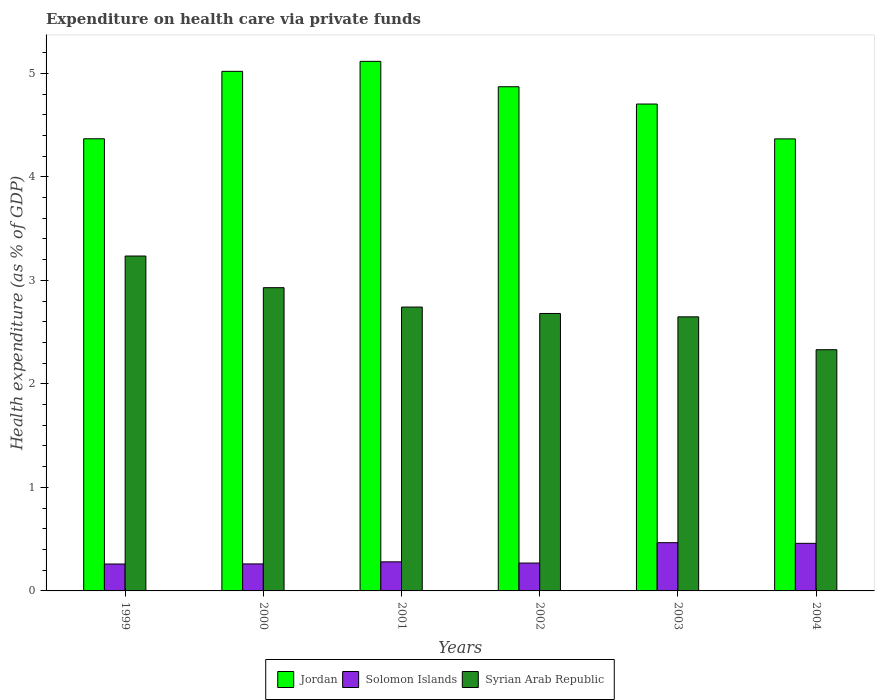How many groups of bars are there?
Offer a very short reply. 6. Are the number of bars per tick equal to the number of legend labels?
Offer a terse response. Yes. How many bars are there on the 2nd tick from the right?
Your answer should be compact. 3. What is the expenditure made on health care in Syrian Arab Republic in 2002?
Provide a short and direct response. 2.68. Across all years, what is the maximum expenditure made on health care in Syrian Arab Republic?
Give a very brief answer. 3.24. Across all years, what is the minimum expenditure made on health care in Syrian Arab Republic?
Your answer should be very brief. 2.33. In which year was the expenditure made on health care in Syrian Arab Republic maximum?
Your answer should be compact. 1999. What is the total expenditure made on health care in Solomon Islands in the graph?
Provide a succinct answer. 2. What is the difference between the expenditure made on health care in Jordan in 2000 and that in 2004?
Give a very brief answer. 0.65. What is the difference between the expenditure made on health care in Jordan in 2002 and the expenditure made on health care in Syrian Arab Republic in 1999?
Offer a terse response. 1.64. What is the average expenditure made on health care in Jordan per year?
Offer a terse response. 4.74. In the year 2003, what is the difference between the expenditure made on health care in Solomon Islands and expenditure made on health care in Syrian Arab Republic?
Keep it short and to the point. -2.18. In how many years, is the expenditure made on health care in Jordan greater than 1.2 %?
Offer a very short reply. 6. What is the ratio of the expenditure made on health care in Jordan in 2000 to that in 2001?
Your answer should be very brief. 0.98. Is the expenditure made on health care in Syrian Arab Republic in 2000 less than that in 2003?
Provide a succinct answer. No. Is the difference between the expenditure made on health care in Solomon Islands in 2001 and 2004 greater than the difference between the expenditure made on health care in Syrian Arab Republic in 2001 and 2004?
Ensure brevity in your answer.  No. What is the difference between the highest and the second highest expenditure made on health care in Solomon Islands?
Keep it short and to the point. 0.01. What is the difference between the highest and the lowest expenditure made on health care in Syrian Arab Republic?
Your response must be concise. 0.91. Is the sum of the expenditure made on health care in Solomon Islands in 2002 and 2004 greater than the maximum expenditure made on health care in Syrian Arab Republic across all years?
Ensure brevity in your answer.  No. What does the 1st bar from the left in 2000 represents?
Your answer should be very brief. Jordan. What does the 2nd bar from the right in 2004 represents?
Offer a terse response. Solomon Islands. How many bars are there?
Your response must be concise. 18. What is the difference between two consecutive major ticks on the Y-axis?
Your response must be concise. 1. Are the values on the major ticks of Y-axis written in scientific E-notation?
Give a very brief answer. No. Does the graph contain grids?
Provide a short and direct response. No. Where does the legend appear in the graph?
Make the answer very short. Bottom center. How many legend labels are there?
Provide a succinct answer. 3. What is the title of the graph?
Offer a terse response. Expenditure on health care via private funds. What is the label or title of the X-axis?
Provide a short and direct response. Years. What is the label or title of the Y-axis?
Your answer should be very brief. Health expenditure (as % of GDP). What is the Health expenditure (as % of GDP) in Jordan in 1999?
Provide a succinct answer. 4.37. What is the Health expenditure (as % of GDP) of Solomon Islands in 1999?
Keep it short and to the point. 0.26. What is the Health expenditure (as % of GDP) of Syrian Arab Republic in 1999?
Your answer should be very brief. 3.24. What is the Health expenditure (as % of GDP) in Jordan in 2000?
Give a very brief answer. 5.02. What is the Health expenditure (as % of GDP) of Solomon Islands in 2000?
Keep it short and to the point. 0.26. What is the Health expenditure (as % of GDP) in Syrian Arab Republic in 2000?
Give a very brief answer. 2.93. What is the Health expenditure (as % of GDP) in Jordan in 2001?
Keep it short and to the point. 5.12. What is the Health expenditure (as % of GDP) of Solomon Islands in 2001?
Provide a short and direct response. 0.28. What is the Health expenditure (as % of GDP) in Syrian Arab Republic in 2001?
Give a very brief answer. 2.74. What is the Health expenditure (as % of GDP) of Jordan in 2002?
Provide a succinct answer. 4.87. What is the Health expenditure (as % of GDP) of Solomon Islands in 2002?
Your answer should be very brief. 0.27. What is the Health expenditure (as % of GDP) in Syrian Arab Republic in 2002?
Provide a succinct answer. 2.68. What is the Health expenditure (as % of GDP) of Jordan in 2003?
Give a very brief answer. 4.7. What is the Health expenditure (as % of GDP) in Solomon Islands in 2003?
Offer a very short reply. 0.47. What is the Health expenditure (as % of GDP) in Syrian Arab Republic in 2003?
Provide a short and direct response. 2.65. What is the Health expenditure (as % of GDP) in Jordan in 2004?
Make the answer very short. 4.37. What is the Health expenditure (as % of GDP) of Solomon Islands in 2004?
Your answer should be compact. 0.46. What is the Health expenditure (as % of GDP) of Syrian Arab Republic in 2004?
Your answer should be compact. 2.33. Across all years, what is the maximum Health expenditure (as % of GDP) of Jordan?
Provide a succinct answer. 5.12. Across all years, what is the maximum Health expenditure (as % of GDP) in Solomon Islands?
Make the answer very short. 0.47. Across all years, what is the maximum Health expenditure (as % of GDP) in Syrian Arab Republic?
Provide a short and direct response. 3.24. Across all years, what is the minimum Health expenditure (as % of GDP) of Jordan?
Ensure brevity in your answer.  4.37. Across all years, what is the minimum Health expenditure (as % of GDP) in Solomon Islands?
Your response must be concise. 0.26. Across all years, what is the minimum Health expenditure (as % of GDP) in Syrian Arab Republic?
Keep it short and to the point. 2.33. What is the total Health expenditure (as % of GDP) of Jordan in the graph?
Your answer should be very brief. 28.44. What is the total Health expenditure (as % of GDP) in Solomon Islands in the graph?
Your response must be concise. 2. What is the total Health expenditure (as % of GDP) in Syrian Arab Republic in the graph?
Keep it short and to the point. 16.57. What is the difference between the Health expenditure (as % of GDP) of Jordan in 1999 and that in 2000?
Offer a very short reply. -0.65. What is the difference between the Health expenditure (as % of GDP) of Solomon Islands in 1999 and that in 2000?
Ensure brevity in your answer.  -0. What is the difference between the Health expenditure (as % of GDP) in Syrian Arab Republic in 1999 and that in 2000?
Offer a terse response. 0.31. What is the difference between the Health expenditure (as % of GDP) of Jordan in 1999 and that in 2001?
Offer a very short reply. -0.75. What is the difference between the Health expenditure (as % of GDP) of Solomon Islands in 1999 and that in 2001?
Keep it short and to the point. -0.02. What is the difference between the Health expenditure (as % of GDP) in Syrian Arab Republic in 1999 and that in 2001?
Keep it short and to the point. 0.49. What is the difference between the Health expenditure (as % of GDP) of Jordan in 1999 and that in 2002?
Your answer should be very brief. -0.5. What is the difference between the Health expenditure (as % of GDP) of Solomon Islands in 1999 and that in 2002?
Keep it short and to the point. -0.01. What is the difference between the Health expenditure (as % of GDP) of Syrian Arab Republic in 1999 and that in 2002?
Provide a succinct answer. 0.56. What is the difference between the Health expenditure (as % of GDP) of Jordan in 1999 and that in 2003?
Your answer should be compact. -0.34. What is the difference between the Health expenditure (as % of GDP) of Solomon Islands in 1999 and that in 2003?
Your answer should be compact. -0.21. What is the difference between the Health expenditure (as % of GDP) in Syrian Arab Republic in 1999 and that in 2003?
Provide a succinct answer. 0.59. What is the difference between the Health expenditure (as % of GDP) in Jordan in 1999 and that in 2004?
Keep it short and to the point. 0. What is the difference between the Health expenditure (as % of GDP) of Solomon Islands in 1999 and that in 2004?
Make the answer very short. -0.2. What is the difference between the Health expenditure (as % of GDP) of Syrian Arab Republic in 1999 and that in 2004?
Keep it short and to the point. 0.91. What is the difference between the Health expenditure (as % of GDP) of Jordan in 2000 and that in 2001?
Provide a short and direct response. -0.1. What is the difference between the Health expenditure (as % of GDP) in Solomon Islands in 2000 and that in 2001?
Give a very brief answer. -0.02. What is the difference between the Health expenditure (as % of GDP) in Syrian Arab Republic in 2000 and that in 2001?
Provide a short and direct response. 0.19. What is the difference between the Health expenditure (as % of GDP) of Jordan in 2000 and that in 2002?
Make the answer very short. 0.15. What is the difference between the Health expenditure (as % of GDP) in Solomon Islands in 2000 and that in 2002?
Keep it short and to the point. -0.01. What is the difference between the Health expenditure (as % of GDP) of Syrian Arab Republic in 2000 and that in 2002?
Ensure brevity in your answer.  0.25. What is the difference between the Health expenditure (as % of GDP) in Jordan in 2000 and that in 2003?
Your answer should be very brief. 0.32. What is the difference between the Health expenditure (as % of GDP) in Solomon Islands in 2000 and that in 2003?
Ensure brevity in your answer.  -0.21. What is the difference between the Health expenditure (as % of GDP) of Syrian Arab Republic in 2000 and that in 2003?
Your response must be concise. 0.28. What is the difference between the Health expenditure (as % of GDP) of Jordan in 2000 and that in 2004?
Ensure brevity in your answer.  0.65. What is the difference between the Health expenditure (as % of GDP) in Solomon Islands in 2000 and that in 2004?
Your answer should be compact. -0.2. What is the difference between the Health expenditure (as % of GDP) of Syrian Arab Republic in 2000 and that in 2004?
Ensure brevity in your answer.  0.6. What is the difference between the Health expenditure (as % of GDP) in Jordan in 2001 and that in 2002?
Your answer should be compact. 0.25. What is the difference between the Health expenditure (as % of GDP) of Solomon Islands in 2001 and that in 2002?
Ensure brevity in your answer.  0.01. What is the difference between the Health expenditure (as % of GDP) of Syrian Arab Republic in 2001 and that in 2002?
Your answer should be very brief. 0.06. What is the difference between the Health expenditure (as % of GDP) of Jordan in 2001 and that in 2003?
Your response must be concise. 0.41. What is the difference between the Health expenditure (as % of GDP) of Solomon Islands in 2001 and that in 2003?
Your answer should be very brief. -0.19. What is the difference between the Health expenditure (as % of GDP) of Syrian Arab Republic in 2001 and that in 2003?
Keep it short and to the point. 0.09. What is the difference between the Health expenditure (as % of GDP) in Jordan in 2001 and that in 2004?
Keep it short and to the point. 0.75. What is the difference between the Health expenditure (as % of GDP) of Solomon Islands in 2001 and that in 2004?
Your answer should be compact. -0.18. What is the difference between the Health expenditure (as % of GDP) in Syrian Arab Republic in 2001 and that in 2004?
Your response must be concise. 0.41. What is the difference between the Health expenditure (as % of GDP) in Jordan in 2002 and that in 2003?
Your answer should be very brief. 0.17. What is the difference between the Health expenditure (as % of GDP) in Solomon Islands in 2002 and that in 2003?
Provide a short and direct response. -0.2. What is the difference between the Health expenditure (as % of GDP) in Syrian Arab Republic in 2002 and that in 2003?
Give a very brief answer. 0.03. What is the difference between the Health expenditure (as % of GDP) in Jordan in 2002 and that in 2004?
Provide a succinct answer. 0.5. What is the difference between the Health expenditure (as % of GDP) of Solomon Islands in 2002 and that in 2004?
Ensure brevity in your answer.  -0.19. What is the difference between the Health expenditure (as % of GDP) of Syrian Arab Republic in 2002 and that in 2004?
Your response must be concise. 0.35. What is the difference between the Health expenditure (as % of GDP) of Jordan in 2003 and that in 2004?
Your answer should be very brief. 0.34. What is the difference between the Health expenditure (as % of GDP) of Solomon Islands in 2003 and that in 2004?
Offer a very short reply. 0.01. What is the difference between the Health expenditure (as % of GDP) in Syrian Arab Republic in 2003 and that in 2004?
Offer a terse response. 0.32. What is the difference between the Health expenditure (as % of GDP) in Jordan in 1999 and the Health expenditure (as % of GDP) in Solomon Islands in 2000?
Provide a succinct answer. 4.11. What is the difference between the Health expenditure (as % of GDP) in Jordan in 1999 and the Health expenditure (as % of GDP) in Syrian Arab Republic in 2000?
Provide a succinct answer. 1.44. What is the difference between the Health expenditure (as % of GDP) in Solomon Islands in 1999 and the Health expenditure (as % of GDP) in Syrian Arab Republic in 2000?
Provide a succinct answer. -2.67. What is the difference between the Health expenditure (as % of GDP) of Jordan in 1999 and the Health expenditure (as % of GDP) of Solomon Islands in 2001?
Offer a very short reply. 4.09. What is the difference between the Health expenditure (as % of GDP) in Jordan in 1999 and the Health expenditure (as % of GDP) in Syrian Arab Republic in 2001?
Your response must be concise. 1.63. What is the difference between the Health expenditure (as % of GDP) of Solomon Islands in 1999 and the Health expenditure (as % of GDP) of Syrian Arab Republic in 2001?
Your answer should be compact. -2.48. What is the difference between the Health expenditure (as % of GDP) in Jordan in 1999 and the Health expenditure (as % of GDP) in Solomon Islands in 2002?
Keep it short and to the point. 4.1. What is the difference between the Health expenditure (as % of GDP) in Jordan in 1999 and the Health expenditure (as % of GDP) in Syrian Arab Republic in 2002?
Your answer should be compact. 1.69. What is the difference between the Health expenditure (as % of GDP) in Solomon Islands in 1999 and the Health expenditure (as % of GDP) in Syrian Arab Republic in 2002?
Your answer should be compact. -2.42. What is the difference between the Health expenditure (as % of GDP) of Jordan in 1999 and the Health expenditure (as % of GDP) of Solomon Islands in 2003?
Ensure brevity in your answer.  3.9. What is the difference between the Health expenditure (as % of GDP) in Jordan in 1999 and the Health expenditure (as % of GDP) in Syrian Arab Republic in 2003?
Offer a terse response. 1.72. What is the difference between the Health expenditure (as % of GDP) of Solomon Islands in 1999 and the Health expenditure (as % of GDP) of Syrian Arab Republic in 2003?
Offer a very short reply. -2.39. What is the difference between the Health expenditure (as % of GDP) in Jordan in 1999 and the Health expenditure (as % of GDP) in Solomon Islands in 2004?
Make the answer very short. 3.91. What is the difference between the Health expenditure (as % of GDP) of Jordan in 1999 and the Health expenditure (as % of GDP) of Syrian Arab Republic in 2004?
Offer a terse response. 2.04. What is the difference between the Health expenditure (as % of GDP) in Solomon Islands in 1999 and the Health expenditure (as % of GDP) in Syrian Arab Republic in 2004?
Keep it short and to the point. -2.07. What is the difference between the Health expenditure (as % of GDP) of Jordan in 2000 and the Health expenditure (as % of GDP) of Solomon Islands in 2001?
Your answer should be compact. 4.74. What is the difference between the Health expenditure (as % of GDP) in Jordan in 2000 and the Health expenditure (as % of GDP) in Syrian Arab Republic in 2001?
Offer a very short reply. 2.28. What is the difference between the Health expenditure (as % of GDP) of Solomon Islands in 2000 and the Health expenditure (as % of GDP) of Syrian Arab Republic in 2001?
Your answer should be very brief. -2.48. What is the difference between the Health expenditure (as % of GDP) of Jordan in 2000 and the Health expenditure (as % of GDP) of Solomon Islands in 2002?
Make the answer very short. 4.75. What is the difference between the Health expenditure (as % of GDP) of Jordan in 2000 and the Health expenditure (as % of GDP) of Syrian Arab Republic in 2002?
Ensure brevity in your answer.  2.34. What is the difference between the Health expenditure (as % of GDP) in Solomon Islands in 2000 and the Health expenditure (as % of GDP) in Syrian Arab Republic in 2002?
Give a very brief answer. -2.42. What is the difference between the Health expenditure (as % of GDP) in Jordan in 2000 and the Health expenditure (as % of GDP) in Solomon Islands in 2003?
Offer a terse response. 4.55. What is the difference between the Health expenditure (as % of GDP) of Jordan in 2000 and the Health expenditure (as % of GDP) of Syrian Arab Republic in 2003?
Provide a succinct answer. 2.37. What is the difference between the Health expenditure (as % of GDP) in Solomon Islands in 2000 and the Health expenditure (as % of GDP) in Syrian Arab Republic in 2003?
Provide a short and direct response. -2.39. What is the difference between the Health expenditure (as % of GDP) of Jordan in 2000 and the Health expenditure (as % of GDP) of Solomon Islands in 2004?
Offer a very short reply. 4.56. What is the difference between the Health expenditure (as % of GDP) in Jordan in 2000 and the Health expenditure (as % of GDP) in Syrian Arab Republic in 2004?
Your response must be concise. 2.69. What is the difference between the Health expenditure (as % of GDP) of Solomon Islands in 2000 and the Health expenditure (as % of GDP) of Syrian Arab Republic in 2004?
Offer a terse response. -2.07. What is the difference between the Health expenditure (as % of GDP) of Jordan in 2001 and the Health expenditure (as % of GDP) of Solomon Islands in 2002?
Offer a very short reply. 4.85. What is the difference between the Health expenditure (as % of GDP) of Jordan in 2001 and the Health expenditure (as % of GDP) of Syrian Arab Republic in 2002?
Provide a short and direct response. 2.44. What is the difference between the Health expenditure (as % of GDP) in Solomon Islands in 2001 and the Health expenditure (as % of GDP) in Syrian Arab Republic in 2002?
Provide a succinct answer. -2.4. What is the difference between the Health expenditure (as % of GDP) in Jordan in 2001 and the Health expenditure (as % of GDP) in Solomon Islands in 2003?
Your response must be concise. 4.65. What is the difference between the Health expenditure (as % of GDP) of Jordan in 2001 and the Health expenditure (as % of GDP) of Syrian Arab Republic in 2003?
Your response must be concise. 2.47. What is the difference between the Health expenditure (as % of GDP) of Solomon Islands in 2001 and the Health expenditure (as % of GDP) of Syrian Arab Republic in 2003?
Provide a succinct answer. -2.37. What is the difference between the Health expenditure (as % of GDP) in Jordan in 2001 and the Health expenditure (as % of GDP) in Solomon Islands in 2004?
Your response must be concise. 4.66. What is the difference between the Health expenditure (as % of GDP) in Jordan in 2001 and the Health expenditure (as % of GDP) in Syrian Arab Republic in 2004?
Your response must be concise. 2.79. What is the difference between the Health expenditure (as % of GDP) in Solomon Islands in 2001 and the Health expenditure (as % of GDP) in Syrian Arab Republic in 2004?
Make the answer very short. -2.05. What is the difference between the Health expenditure (as % of GDP) in Jordan in 2002 and the Health expenditure (as % of GDP) in Solomon Islands in 2003?
Offer a terse response. 4.4. What is the difference between the Health expenditure (as % of GDP) of Jordan in 2002 and the Health expenditure (as % of GDP) of Syrian Arab Republic in 2003?
Your answer should be compact. 2.22. What is the difference between the Health expenditure (as % of GDP) in Solomon Islands in 2002 and the Health expenditure (as % of GDP) in Syrian Arab Republic in 2003?
Your answer should be compact. -2.38. What is the difference between the Health expenditure (as % of GDP) of Jordan in 2002 and the Health expenditure (as % of GDP) of Solomon Islands in 2004?
Provide a short and direct response. 4.41. What is the difference between the Health expenditure (as % of GDP) in Jordan in 2002 and the Health expenditure (as % of GDP) in Syrian Arab Republic in 2004?
Make the answer very short. 2.54. What is the difference between the Health expenditure (as % of GDP) of Solomon Islands in 2002 and the Health expenditure (as % of GDP) of Syrian Arab Republic in 2004?
Provide a succinct answer. -2.06. What is the difference between the Health expenditure (as % of GDP) of Jordan in 2003 and the Health expenditure (as % of GDP) of Solomon Islands in 2004?
Make the answer very short. 4.24. What is the difference between the Health expenditure (as % of GDP) of Jordan in 2003 and the Health expenditure (as % of GDP) of Syrian Arab Republic in 2004?
Offer a terse response. 2.37. What is the difference between the Health expenditure (as % of GDP) of Solomon Islands in 2003 and the Health expenditure (as % of GDP) of Syrian Arab Republic in 2004?
Offer a very short reply. -1.86. What is the average Health expenditure (as % of GDP) in Jordan per year?
Offer a very short reply. 4.74. What is the average Health expenditure (as % of GDP) in Solomon Islands per year?
Offer a very short reply. 0.33. What is the average Health expenditure (as % of GDP) of Syrian Arab Republic per year?
Provide a short and direct response. 2.76. In the year 1999, what is the difference between the Health expenditure (as % of GDP) in Jordan and Health expenditure (as % of GDP) in Solomon Islands?
Your answer should be very brief. 4.11. In the year 1999, what is the difference between the Health expenditure (as % of GDP) of Jordan and Health expenditure (as % of GDP) of Syrian Arab Republic?
Provide a short and direct response. 1.13. In the year 1999, what is the difference between the Health expenditure (as % of GDP) of Solomon Islands and Health expenditure (as % of GDP) of Syrian Arab Republic?
Ensure brevity in your answer.  -2.98. In the year 2000, what is the difference between the Health expenditure (as % of GDP) of Jordan and Health expenditure (as % of GDP) of Solomon Islands?
Offer a terse response. 4.76. In the year 2000, what is the difference between the Health expenditure (as % of GDP) in Jordan and Health expenditure (as % of GDP) in Syrian Arab Republic?
Offer a terse response. 2.09. In the year 2000, what is the difference between the Health expenditure (as % of GDP) in Solomon Islands and Health expenditure (as % of GDP) in Syrian Arab Republic?
Your response must be concise. -2.67. In the year 2001, what is the difference between the Health expenditure (as % of GDP) in Jordan and Health expenditure (as % of GDP) in Solomon Islands?
Offer a very short reply. 4.83. In the year 2001, what is the difference between the Health expenditure (as % of GDP) of Jordan and Health expenditure (as % of GDP) of Syrian Arab Republic?
Your answer should be compact. 2.37. In the year 2001, what is the difference between the Health expenditure (as % of GDP) in Solomon Islands and Health expenditure (as % of GDP) in Syrian Arab Republic?
Your answer should be compact. -2.46. In the year 2002, what is the difference between the Health expenditure (as % of GDP) in Jordan and Health expenditure (as % of GDP) in Solomon Islands?
Give a very brief answer. 4.6. In the year 2002, what is the difference between the Health expenditure (as % of GDP) of Jordan and Health expenditure (as % of GDP) of Syrian Arab Republic?
Your answer should be compact. 2.19. In the year 2002, what is the difference between the Health expenditure (as % of GDP) in Solomon Islands and Health expenditure (as % of GDP) in Syrian Arab Republic?
Your response must be concise. -2.41. In the year 2003, what is the difference between the Health expenditure (as % of GDP) in Jordan and Health expenditure (as % of GDP) in Solomon Islands?
Provide a short and direct response. 4.24. In the year 2003, what is the difference between the Health expenditure (as % of GDP) of Jordan and Health expenditure (as % of GDP) of Syrian Arab Republic?
Offer a terse response. 2.06. In the year 2003, what is the difference between the Health expenditure (as % of GDP) of Solomon Islands and Health expenditure (as % of GDP) of Syrian Arab Republic?
Give a very brief answer. -2.18. In the year 2004, what is the difference between the Health expenditure (as % of GDP) in Jordan and Health expenditure (as % of GDP) in Solomon Islands?
Offer a very short reply. 3.91. In the year 2004, what is the difference between the Health expenditure (as % of GDP) of Jordan and Health expenditure (as % of GDP) of Syrian Arab Republic?
Offer a very short reply. 2.04. In the year 2004, what is the difference between the Health expenditure (as % of GDP) of Solomon Islands and Health expenditure (as % of GDP) of Syrian Arab Republic?
Your answer should be compact. -1.87. What is the ratio of the Health expenditure (as % of GDP) of Jordan in 1999 to that in 2000?
Your response must be concise. 0.87. What is the ratio of the Health expenditure (as % of GDP) in Syrian Arab Republic in 1999 to that in 2000?
Your response must be concise. 1.1. What is the ratio of the Health expenditure (as % of GDP) in Jordan in 1999 to that in 2001?
Offer a very short reply. 0.85. What is the ratio of the Health expenditure (as % of GDP) of Solomon Islands in 1999 to that in 2001?
Offer a very short reply. 0.93. What is the ratio of the Health expenditure (as % of GDP) in Syrian Arab Republic in 1999 to that in 2001?
Your answer should be compact. 1.18. What is the ratio of the Health expenditure (as % of GDP) in Jordan in 1999 to that in 2002?
Keep it short and to the point. 0.9. What is the ratio of the Health expenditure (as % of GDP) of Solomon Islands in 1999 to that in 2002?
Offer a very short reply. 0.97. What is the ratio of the Health expenditure (as % of GDP) of Syrian Arab Republic in 1999 to that in 2002?
Provide a short and direct response. 1.21. What is the ratio of the Health expenditure (as % of GDP) of Jordan in 1999 to that in 2003?
Your answer should be compact. 0.93. What is the ratio of the Health expenditure (as % of GDP) of Solomon Islands in 1999 to that in 2003?
Ensure brevity in your answer.  0.56. What is the ratio of the Health expenditure (as % of GDP) in Syrian Arab Republic in 1999 to that in 2003?
Offer a terse response. 1.22. What is the ratio of the Health expenditure (as % of GDP) of Solomon Islands in 1999 to that in 2004?
Provide a short and direct response. 0.57. What is the ratio of the Health expenditure (as % of GDP) in Syrian Arab Republic in 1999 to that in 2004?
Ensure brevity in your answer.  1.39. What is the ratio of the Health expenditure (as % of GDP) in Jordan in 2000 to that in 2001?
Offer a terse response. 0.98. What is the ratio of the Health expenditure (as % of GDP) in Solomon Islands in 2000 to that in 2001?
Your answer should be very brief. 0.93. What is the ratio of the Health expenditure (as % of GDP) of Syrian Arab Republic in 2000 to that in 2001?
Keep it short and to the point. 1.07. What is the ratio of the Health expenditure (as % of GDP) of Jordan in 2000 to that in 2002?
Offer a very short reply. 1.03. What is the ratio of the Health expenditure (as % of GDP) of Solomon Islands in 2000 to that in 2002?
Ensure brevity in your answer.  0.97. What is the ratio of the Health expenditure (as % of GDP) in Syrian Arab Republic in 2000 to that in 2002?
Offer a terse response. 1.09. What is the ratio of the Health expenditure (as % of GDP) in Jordan in 2000 to that in 2003?
Your response must be concise. 1.07. What is the ratio of the Health expenditure (as % of GDP) in Solomon Islands in 2000 to that in 2003?
Provide a succinct answer. 0.56. What is the ratio of the Health expenditure (as % of GDP) in Syrian Arab Republic in 2000 to that in 2003?
Give a very brief answer. 1.11. What is the ratio of the Health expenditure (as % of GDP) of Jordan in 2000 to that in 2004?
Your answer should be very brief. 1.15. What is the ratio of the Health expenditure (as % of GDP) of Solomon Islands in 2000 to that in 2004?
Offer a terse response. 0.57. What is the ratio of the Health expenditure (as % of GDP) in Syrian Arab Republic in 2000 to that in 2004?
Keep it short and to the point. 1.26. What is the ratio of the Health expenditure (as % of GDP) of Jordan in 2001 to that in 2002?
Your response must be concise. 1.05. What is the ratio of the Health expenditure (as % of GDP) in Solomon Islands in 2001 to that in 2002?
Give a very brief answer. 1.04. What is the ratio of the Health expenditure (as % of GDP) of Syrian Arab Republic in 2001 to that in 2002?
Your response must be concise. 1.02. What is the ratio of the Health expenditure (as % of GDP) of Jordan in 2001 to that in 2003?
Your response must be concise. 1.09. What is the ratio of the Health expenditure (as % of GDP) of Solomon Islands in 2001 to that in 2003?
Provide a short and direct response. 0.6. What is the ratio of the Health expenditure (as % of GDP) of Syrian Arab Republic in 2001 to that in 2003?
Provide a short and direct response. 1.04. What is the ratio of the Health expenditure (as % of GDP) in Jordan in 2001 to that in 2004?
Keep it short and to the point. 1.17. What is the ratio of the Health expenditure (as % of GDP) of Solomon Islands in 2001 to that in 2004?
Your answer should be compact. 0.61. What is the ratio of the Health expenditure (as % of GDP) of Syrian Arab Republic in 2001 to that in 2004?
Keep it short and to the point. 1.18. What is the ratio of the Health expenditure (as % of GDP) in Jordan in 2002 to that in 2003?
Give a very brief answer. 1.04. What is the ratio of the Health expenditure (as % of GDP) of Solomon Islands in 2002 to that in 2003?
Provide a short and direct response. 0.58. What is the ratio of the Health expenditure (as % of GDP) in Syrian Arab Republic in 2002 to that in 2003?
Your response must be concise. 1.01. What is the ratio of the Health expenditure (as % of GDP) in Jordan in 2002 to that in 2004?
Your answer should be very brief. 1.12. What is the ratio of the Health expenditure (as % of GDP) of Solomon Islands in 2002 to that in 2004?
Offer a terse response. 0.59. What is the ratio of the Health expenditure (as % of GDP) of Syrian Arab Republic in 2002 to that in 2004?
Provide a succinct answer. 1.15. What is the ratio of the Health expenditure (as % of GDP) in Jordan in 2003 to that in 2004?
Make the answer very short. 1.08. What is the ratio of the Health expenditure (as % of GDP) in Solomon Islands in 2003 to that in 2004?
Provide a short and direct response. 1.01. What is the ratio of the Health expenditure (as % of GDP) in Syrian Arab Republic in 2003 to that in 2004?
Your answer should be very brief. 1.14. What is the difference between the highest and the second highest Health expenditure (as % of GDP) in Jordan?
Make the answer very short. 0.1. What is the difference between the highest and the second highest Health expenditure (as % of GDP) of Solomon Islands?
Offer a terse response. 0.01. What is the difference between the highest and the second highest Health expenditure (as % of GDP) of Syrian Arab Republic?
Make the answer very short. 0.31. What is the difference between the highest and the lowest Health expenditure (as % of GDP) of Jordan?
Your answer should be very brief. 0.75. What is the difference between the highest and the lowest Health expenditure (as % of GDP) of Solomon Islands?
Ensure brevity in your answer.  0.21. What is the difference between the highest and the lowest Health expenditure (as % of GDP) of Syrian Arab Republic?
Keep it short and to the point. 0.91. 